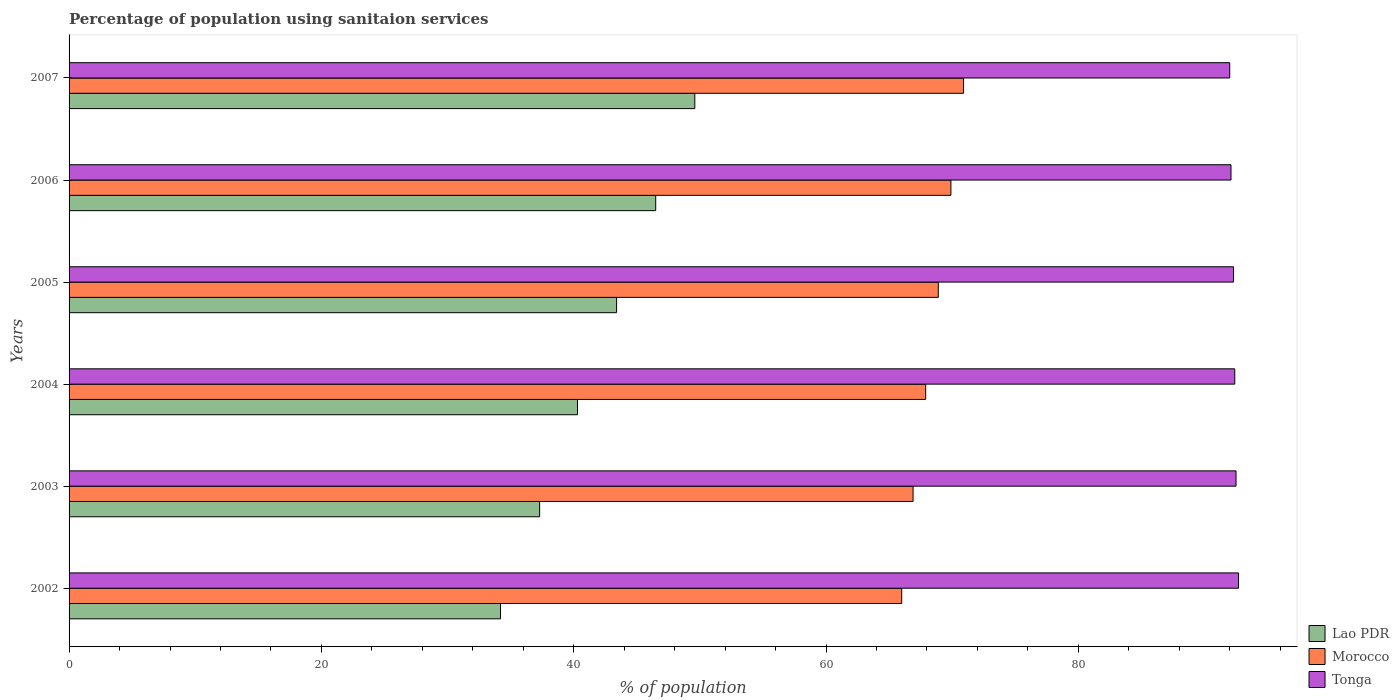How many groups of bars are there?
Your response must be concise. 6. Are the number of bars on each tick of the Y-axis equal?
Your answer should be very brief. Yes. What is the label of the 4th group of bars from the top?
Provide a short and direct response. 2004. In how many cases, is the number of bars for a given year not equal to the number of legend labels?
Keep it short and to the point. 0. What is the percentage of population using sanitaion services in Tonga in 2004?
Your response must be concise. 92.4. Across all years, what is the maximum percentage of population using sanitaion services in Lao PDR?
Your answer should be very brief. 49.6. Across all years, what is the minimum percentage of population using sanitaion services in Tonga?
Give a very brief answer. 92. In which year was the percentage of population using sanitaion services in Tonga maximum?
Your answer should be compact. 2002. What is the total percentage of population using sanitaion services in Morocco in the graph?
Offer a terse response. 410.5. What is the difference between the percentage of population using sanitaion services in Morocco in 2002 and that in 2004?
Give a very brief answer. -1.9. What is the difference between the percentage of population using sanitaion services in Morocco in 2006 and the percentage of population using sanitaion services in Tonga in 2003?
Provide a short and direct response. -22.6. What is the average percentage of population using sanitaion services in Morocco per year?
Keep it short and to the point. 68.42. In the year 2002, what is the difference between the percentage of population using sanitaion services in Lao PDR and percentage of population using sanitaion services in Morocco?
Offer a very short reply. -31.8. What is the ratio of the percentage of population using sanitaion services in Tonga in 2004 to that in 2007?
Give a very brief answer. 1. What is the difference between the highest and the second highest percentage of population using sanitaion services in Lao PDR?
Your answer should be very brief. 3.1. What is the difference between the highest and the lowest percentage of population using sanitaion services in Morocco?
Ensure brevity in your answer.  4.9. In how many years, is the percentage of population using sanitaion services in Lao PDR greater than the average percentage of population using sanitaion services in Lao PDR taken over all years?
Keep it short and to the point. 3. What does the 1st bar from the top in 2005 represents?
Your answer should be very brief. Tonga. What does the 3rd bar from the bottom in 2005 represents?
Provide a short and direct response. Tonga. How many bars are there?
Provide a succinct answer. 18. How many years are there in the graph?
Offer a very short reply. 6. What is the difference between two consecutive major ticks on the X-axis?
Offer a terse response. 20. Are the values on the major ticks of X-axis written in scientific E-notation?
Your response must be concise. No. Does the graph contain grids?
Your answer should be very brief. No. How many legend labels are there?
Provide a short and direct response. 3. What is the title of the graph?
Give a very brief answer. Percentage of population using sanitaion services. What is the label or title of the X-axis?
Keep it short and to the point. % of population. What is the label or title of the Y-axis?
Your answer should be compact. Years. What is the % of population of Lao PDR in 2002?
Your response must be concise. 34.2. What is the % of population of Tonga in 2002?
Ensure brevity in your answer.  92.7. What is the % of population in Lao PDR in 2003?
Offer a terse response. 37.3. What is the % of population of Morocco in 2003?
Your answer should be very brief. 66.9. What is the % of population of Tonga in 2003?
Your response must be concise. 92.5. What is the % of population in Lao PDR in 2004?
Offer a terse response. 40.3. What is the % of population of Morocco in 2004?
Your response must be concise. 67.9. What is the % of population in Tonga in 2004?
Make the answer very short. 92.4. What is the % of population of Lao PDR in 2005?
Offer a very short reply. 43.4. What is the % of population in Morocco in 2005?
Offer a terse response. 68.9. What is the % of population in Tonga in 2005?
Make the answer very short. 92.3. What is the % of population of Lao PDR in 2006?
Keep it short and to the point. 46.5. What is the % of population of Morocco in 2006?
Offer a very short reply. 69.9. What is the % of population of Tonga in 2006?
Offer a terse response. 92.1. What is the % of population of Lao PDR in 2007?
Provide a short and direct response. 49.6. What is the % of population in Morocco in 2007?
Offer a very short reply. 70.9. What is the % of population of Tonga in 2007?
Your response must be concise. 92. Across all years, what is the maximum % of population in Lao PDR?
Your answer should be compact. 49.6. Across all years, what is the maximum % of population of Morocco?
Your response must be concise. 70.9. Across all years, what is the maximum % of population in Tonga?
Provide a short and direct response. 92.7. Across all years, what is the minimum % of population in Lao PDR?
Offer a terse response. 34.2. Across all years, what is the minimum % of population in Tonga?
Offer a very short reply. 92. What is the total % of population of Lao PDR in the graph?
Make the answer very short. 251.3. What is the total % of population of Morocco in the graph?
Provide a short and direct response. 410.5. What is the total % of population of Tonga in the graph?
Your answer should be compact. 554. What is the difference between the % of population of Morocco in 2002 and that in 2003?
Your answer should be very brief. -0.9. What is the difference between the % of population of Morocco in 2002 and that in 2004?
Keep it short and to the point. -1.9. What is the difference between the % of population in Tonga in 2002 and that in 2004?
Offer a terse response. 0.3. What is the difference between the % of population in Lao PDR in 2002 and that in 2005?
Give a very brief answer. -9.2. What is the difference between the % of population of Lao PDR in 2002 and that in 2006?
Your response must be concise. -12.3. What is the difference between the % of population of Morocco in 2002 and that in 2006?
Make the answer very short. -3.9. What is the difference between the % of population in Lao PDR in 2002 and that in 2007?
Your response must be concise. -15.4. What is the difference between the % of population of Morocco in 2002 and that in 2007?
Ensure brevity in your answer.  -4.9. What is the difference between the % of population of Tonga in 2002 and that in 2007?
Your answer should be very brief. 0.7. What is the difference between the % of population in Morocco in 2003 and that in 2004?
Keep it short and to the point. -1. What is the difference between the % of population of Lao PDR in 2003 and that in 2005?
Ensure brevity in your answer.  -6.1. What is the difference between the % of population in Tonga in 2003 and that in 2005?
Offer a very short reply. 0.2. What is the difference between the % of population in Morocco in 2003 and that in 2007?
Make the answer very short. -4. What is the difference between the % of population of Lao PDR in 2004 and that in 2007?
Offer a very short reply. -9.3. What is the difference between the % of population of Lao PDR in 2005 and that in 2006?
Give a very brief answer. -3.1. What is the difference between the % of population of Morocco in 2005 and that in 2006?
Provide a short and direct response. -1. What is the difference between the % of population of Tonga in 2005 and that in 2006?
Offer a terse response. 0.2. What is the difference between the % of population of Lao PDR in 2005 and that in 2007?
Your answer should be very brief. -6.2. What is the difference between the % of population in Morocco in 2005 and that in 2007?
Your answer should be compact. -2. What is the difference between the % of population of Tonga in 2005 and that in 2007?
Your response must be concise. 0.3. What is the difference between the % of population of Lao PDR in 2006 and that in 2007?
Give a very brief answer. -3.1. What is the difference between the % of population of Tonga in 2006 and that in 2007?
Give a very brief answer. 0.1. What is the difference between the % of population in Lao PDR in 2002 and the % of population in Morocco in 2003?
Offer a very short reply. -32.7. What is the difference between the % of population in Lao PDR in 2002 and the % of population in Tonga in 2003?
Give a very brief answer. -58.3. What is the difference between the % of population in Morocco in 2002 and the % of population in Tonga in 2003?
Offer a terse response. -26.5. What is the difference between the % of population in Lao PDR in 2002 and the % of population in Morocco in 2004?
Your response must be concise. -33.7. What is the difference between the % of population of Lao PDR in 2002 and the % of population of Tonga in 2004?
Offer a very short reply. -58.2. What is the difference between the % of population of Morocco in 2002 and the % of population of Tonga in 2004?
Your answer should be very brief. -26.4. What is the difference between the % of population of Lao PDR in 2002 and the % of population of Morocco in 2005?
Make the answer very short. -34.7. What is the difference between the % of population of Lao PDR in 2002 and the % of population of Tonga in 2005?
Your response must be concise. -58.1. What is the difference between the % of population in Morocco in 2002 and the % of population in Tonga in 2005?
Your answer should be very brief. -26.3. What is the difference between the % of population in Lao PDR in 2002 and the % of population in Morocco in 2006?
Provide a short and direct response. -35.7. What is the difference between the % of population in Lao PDR in 2002 and the % of population in Tonga in 2006?
Offer a terse response. -57.9. What is the difference between the % of population in Morocco in 2002 and the % of population in Tonga in 2006?
Give a very brief answer. -26.1. What is the difference between the % of population of Lao PDR in 2002 and the % of population of Morocco in 2007?
Your answer should be compact. -36.7. What is the difference between the % of population of Lao PDR in 2002 and the % of population of Tonga in 2007?
Provide a short and direct response. -57.8. What is the difference between the % of population in Lao PDR in 2003 and the % of population in Morocco in 2004?
Provide a short and direct response. -30.6. What is the difference between the % of population in Lao PDR in 2003 and the % of population in Tonga in 2004?
Offer a terse response. -55.1. What is the difference between the % of population of Morocco in 2003 and the % of population of Tonga in 2004?
Provide a short and direct response. -25.5. What is the difference between the % of population of Lao PDR in 2003 and the % of population of Morocco in 2005?
Your response must be concise. -31.6. What is the difference between the % of population of Lao PDR in 2003 and the % of population of Tonga in 2005?
Your response must be concise. -55. What is the difference between the % of population in Morocco in 2003 and the % of population in Tonga in 2005?
Give a very brief answer. -25.4. What is the difference between the % of population of Lao PDR in 2003 and the % of population of Morocco in 2006?
Give a very brief answer. -32.6. What is the difference between the % of population in Lao PDR in 2003 and the % of population in Tonga in 2006?
Keep it short and to the point. -54.8. What is the difference between the % of population of Morocco in 2003 and the % of population of Tonga in 2006?
Keep it short and to the point. -25.2. What is the difference between the % of population in Lao PDR in 2003 and the % of population in Morocco in 2007?
Your answer should be compact. -33.6. What is the difference between the % of population in Lao PDR in 2003 and the % of population in Tonga in 2007?
Your response must be concise. -54.7. What is the difference between the % of population of Morocco in 2003 and the % of population of Tonga in 2007?
Your answer should be compact. -25.1. What is the difference between the % of population of Lao PDR in 2004 and the % of population of Morocco in 2005?
Offer a terse response. -28.6. What is the difference between the % of population in Lao PDR in 2004 and the % of population in Tonga in 2005?
Offer a terse response. -52. What is the difference between the % of population of Morocco in 2004 and the % of population of Tonga in 2005?
Keep it short and to the point. -24.4. What is the difference between the % of population of Lao PDR in 2004 and the % of population of Morocco in 2006?
Give a very brief answer. -29.6. What is the difference between the % of population in Lao PDR in 2004 and the % of population in Tonga in 2006?
Keep it short and to the point. -51.8. What is the difference between the % of population of Morocco in 2004 and the % of population of Tonga in 2006?
Provide a succinct answer. -24.2. What is the difference between the % of population of Lao PDR in 2004 and the % of population of Morocco in 2007?
Make the answer very short. -30.6. What is the difference between the % of population of Lao PDR in 2004 and the % of population of Tonga in 2007?
Your answer should be very brief. -51.7. What is the difference between the % of population in Morocco in 2004 and the % of population in Tonga in 2007?
Ensure brevity in your answer.  -24.1. What is the difference between the % of population in Lao PDR in 2005 and the % of population in Morocco in 2006?
Make the answer very short. -26.5. What is the difference between the % of population in Lao PDR in 2005 and the % of population in Tonga in 2006?
Offer a terse response. -48.7. What is the difference between the % of population of Morocco in 2005 and the % of population of Tonga in 2006?
Give a very brief answer. -23.2. What is the difference between the % of population in Lao PDR in 2005 and the % of population in Morocco in 2007?
Make the answer very short. -27.5. What is the difference between the % of population in Lao PDR in 2005 and the % of population in Tonga in 2007?
Ensure brevity in your answer.  -48.6. What is the difference between the % of population in Morocco in 2005 and the % of population in Tonga in 2007?
Offer a very short reply. -23.1. What is the difference between the % of population of Lao PDR in 2006 and the % of population of Morocco in 2007?
Provide a succinct answer. -24.4. What is the difference between the % of population in Lao PDR in 2006 and the % of population in Tonga in 2007?
Offer a terse response. -45.5. What is the difference between the % of population in Morocco in 2006 and the % of population in Tonga in 2007?
Provide a succinct answer. -22.1. What is the average % of population of Lao PDR per year?
Your answer should be compact. 41.88. What is the average % of population in Morocco per year?
Offer a terse response. 68.42. What is the average % of population of Tonga per year?
Offer a very short reply. 92.33. In the year 2002, what is the difference between the % of population in Lao PDR and % of population in Morocco?
Your response must be concise. -31.8. In the year 2002, what is the difference between the % of population of Lao PDR and % of population of Tonga?
Offer a very short reply. -58.5. In the year 2002, what is the difference between the % of population in Morocco and % of population in Tonga?
Make the answer very short. -26.7. In the year 2003, what is the difference between the % of population of Lao PDR and % of population of Morocco?
Make the answer very short. -29.6. In the year 2003, what is the difference between the % of population of Lao PDR and % of population of Tonga?
Offer a very short reply. -55.2. In the year 2003, what is the difference between the % of population in Morocco and % of population in Tonga?
Ensure brevity in your answer.  -25.6. In the year 2004, what is the difference between the % of population in Lao PDR and % of population in Morocco?
Provide a short and direct response. -27.6. In the year 2004, what is the difference between the % of population in Lao PDR and % of population in Tonga?
Your response must be concise. -52.1. In the year 2004, what is the difference between the % of population of Morocco and % of population of Tonga?
Ensure brevity in your answer.  -24.5. In the year 2005, what is the difference between the % of population in Lao PDR and % of population in Morocco?
Your answer should be compact. -25.5. In the year 2005, what is the difference between the % of population in Lao PDR and % of population in Tonga?
Offer a terse response. -48.9. In the year 2005, what is the difference between the % of population in Morocco and % of population in Tonga?
Provide a succinct answer. -23.4. In the year 2006, what is the difference between the % of population of Lao PDR and % of population of Morocco?
Offer a terse response. -23.4. In the year 2006, what is the difference between the % of population of Lao PDR and % of population of Tonga?
Ensure brevity in your answer.  -45.6. In the year 2006, what is the difference between the % of population in Morocco and % of population in Tonga?
Give a very brief answer. -22.2. In the year 2007, what is the difference between the % of population of Lao PDR and % of population of Morocco?
Give a very brief answer. -21.3. In the year 2007, what is the difference between the % of population in Lao PDR and % of population in Tonga?
Keep it short and to the point. -42.4. In the year 2007, what is the difference between the % of population of Morocco and % of population of Tonga?
Give a very brief answer. -21.1. What is the ratio of the % of population in Lao PDR in 2002 to that in 2003?
Make the answer very short. 0.92. What is the ratio of the % of population in Morocco in 2002 to that in 2003?
Your answer should be very brief. 0.99. What is the ratio of the % of population in Lao PDR in 2002 to that in 2004?
Provide a short and direct response. 0.85. What is the ratio of the % of population of Morocco in 2002 to that in 2004?
Your answer should be compact. 0.97. What is the ratio of the % of population of Tonga in 2002 to that in 2004?
Keep it short and to the point. 1. What is the ratio of the % of population in Lao PDR in 2002 to that in 2005?
Offer a terse response. 0.79. What is the ratio of the % of population of Morocco in 2002 to that in 2005?
Ensure brevity in your answer.  0.96. What is the ratio of the % of population of Tonga in 2002 to that in 2005?
Provide a succinct answer. 1. What is the ratio of the % of population in Lao PDR in 2002 to that in 2006?
Offer a terse response. 0.74. What is the ratio of the % of population in Morocco in 2002 to that in 2006?
Keep it short and to the point. 0.94. What is the ratio of the % of population of Tonga in 2002 to that in 2006?
Offer a terse response. 1.01. What is the ratio of the % of population of Lao PDR in 2002 to that in 2007?
Your answer should be very brief. 0.69. What is the ratio of the % of population of Morocco in 2002 to that in 2007?
Your response must be concise. 0.93. What is the ratio of the % of population in Tonga in 2002 to that in 2007?
Ensure brevity in your answer.  1.01. What is the ratio of the % of population in Lao PDR in 2003 to that in 2004?
Ensure brevity in your answer.  0.93. What is the ratio of the % of population of Tonga in 2003 to that in 2004?
Ensure brevity in your answer.  1. What is the ratio of the % of population in Lao PDR in 2003 to that in 2005?
Your response must be concise. 0.86. What is the ratio of the % of population of Morocco in 2003 to that in 2005?
Offer a very short reply. 0.97. What is the ratio of the % of population of Lao PDR in 2003 to that in 2006?
Your response must be concise. 0.8. What is the ratio of the % of population in Morocco in 2003 to that in 2006?
Your answer should be compact. 0.96. What is the ratio of the % of population of Tonga in 2003 to that in 2006?
Keep it short and to the point. 1. What is the ratio of the % of population of Lao PDR in 2003 to that in 2007?
Keep it short and to the point. 0.75. What is the ratio of the % of population in Morocco in 2003 to that in 2007?
Provide a succinct answer. 0.94. What is the ratio of the % of population in Tonga in 2003 to that in 2007?
Give a very brief answer. 1.01. What is the ratio of the % of population in Morocco in 2004 to that in 2005?
Your answer should be very brief. 0.99. What is the ratio of the % of population of Tonga in 2004 to that in 2005?
Offer a very short reply. 1. What is the ratio of the % of population in Lao PDR in 2004 to that in 2006?
Provide a succinct answer. 0.87. What is the ratio of the % of population of Morocco in 2004 to that in 2006?
Provide a succinct answer. 0.97. What is the ratio of the % of population in Tonga in 2004 to that in 2006?
Your answer should be compact. 1. What is the ratio of the % of population in Lao PDR in 2004 to that in 2007?
Provide a short and direct response. 0.81. What is the ratio of the % of population in Morocco in 2004 to that in 2007?
Make the answer very short. 0.96. What is the ratio of the % of population of Morocco in 2005 to that in 2006?
Offer a very short reply. 0.99. What is the ratio of the % of population in Tonga in 2005 to that in 2006?
Your answer should be very brief. 1. What is the ratio of the % of population in Morocco in 2005 to that in 2007?
Your answer should be compact. 0.97. What is the ratio of the % of population in Lao PDR in 2006 to that in 2007?
Your answer should be compact. 0.94. What is the ratio of the % of population in Morocco in 2006 to that in 2007?
Your response must be concise. 0.99. What is the difference between the highest and the second highest % of population in Lao PDR?
Provide a succinct answer. 3.1. What is the difference between the highest and the second highest % of population of Tonga?
Your response must be concise. 0.2. What is the difference between the highest and the lowest % of population of Tonga?
Ensure brevity in your answer.  0.7. 